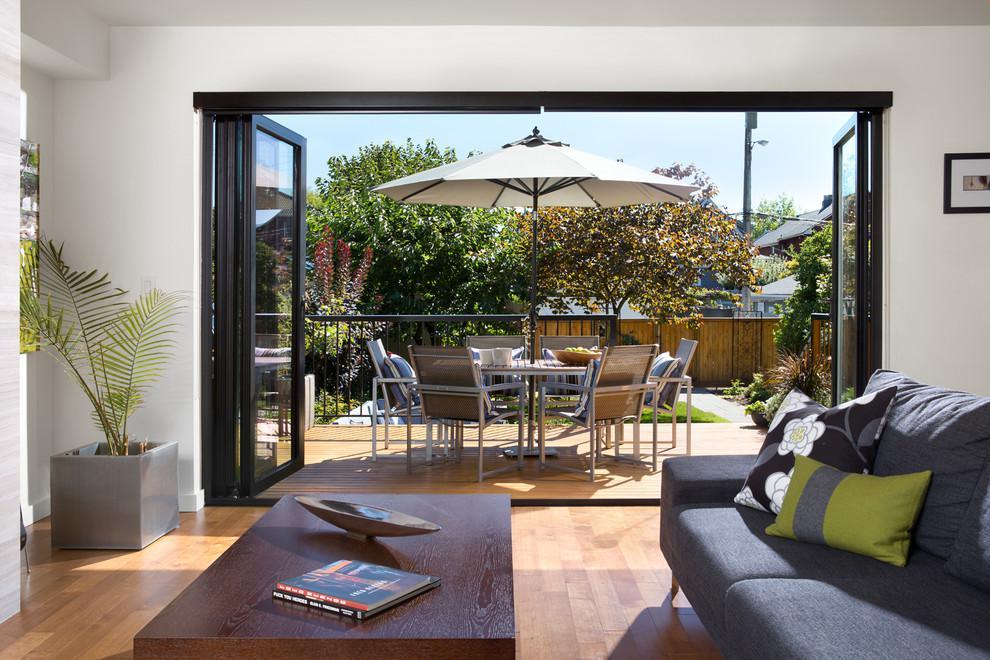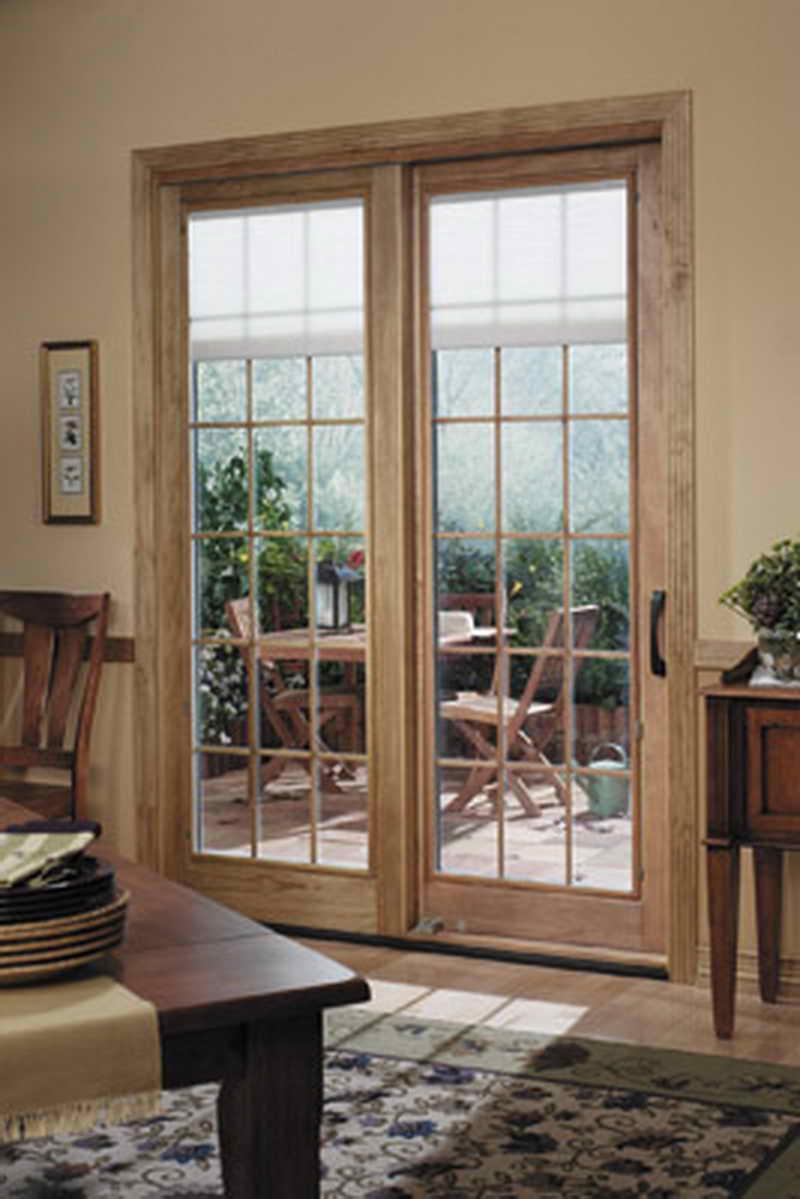The first image is the image on the left, the second image is the image on the right. Evaluate the accuracy of this statement regarding the images: "There are six glass panes in a row in the right image.". Is it true? Answer yes or no. No. 